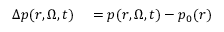Convert formula to latex. <formula><loc_0><loc_0><loc_500><loc_500>\begin{array} { r l } { \Delta p ( r , \Omega , t ) } & = p ( r , \Omega , t ) - p _ { 0 } ( r ) } \end{array}</formula> 